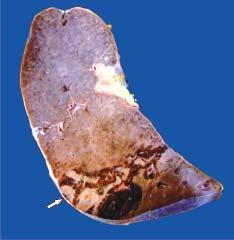s the margin congested?
Answer the question using a single word or phrase. Yes 